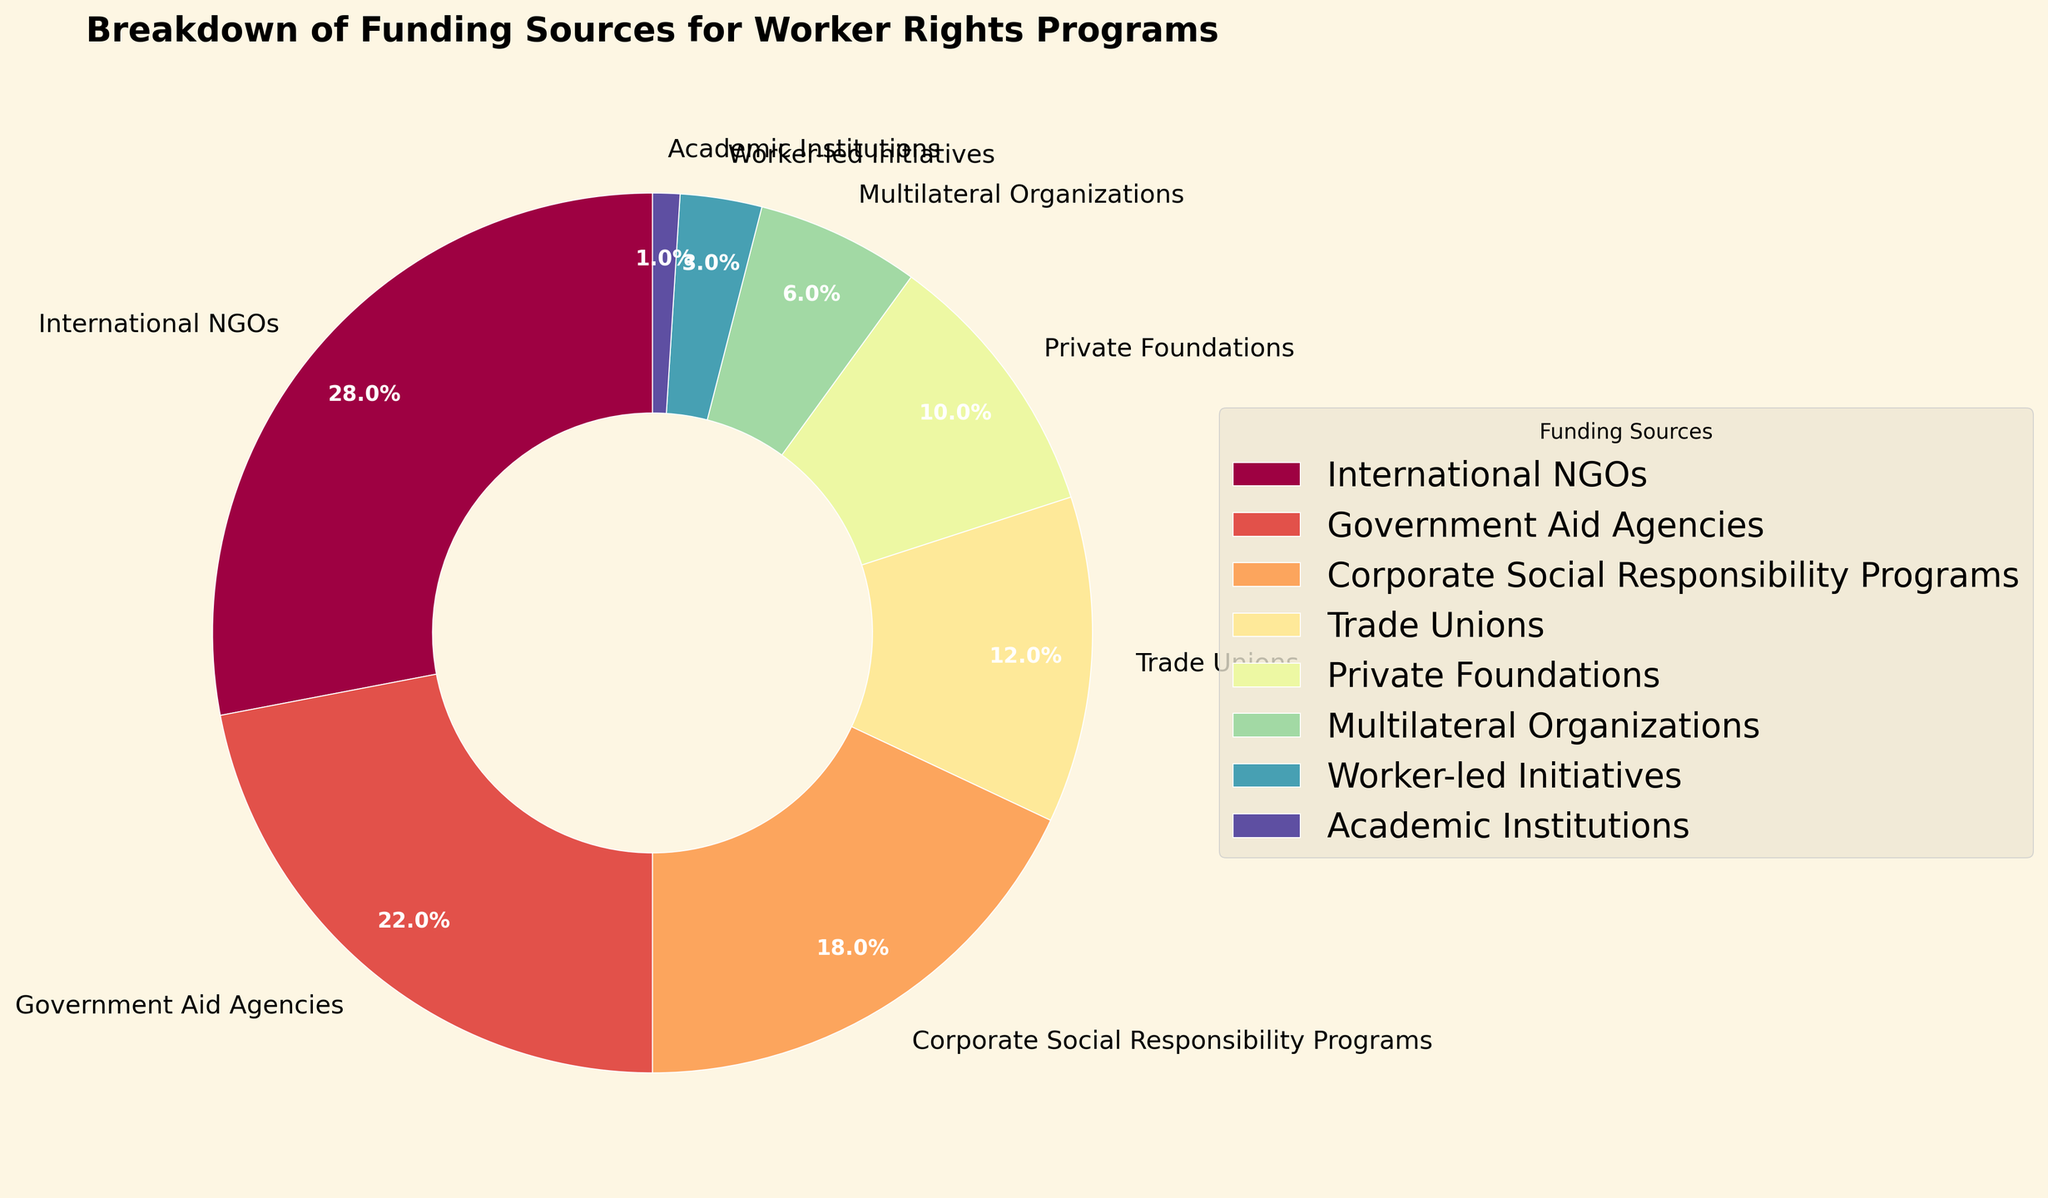What percentage of funding comes from International NGOs? The pie chart shows that International NGOs contribute 28% to the total funding.
Answer: 28% Which funding source contributes the least? By referring to the chart, we can see that Academic Institutions have the smallest slice, contributing 1%.
Answer: Academic Institutions How much more funding do Government Aid Agencies provide compared to Worker-led Initiatives? The percentages for Government Aid Agencies and Worker-led Initiatives are 22% and 3%, respectively. The difference is 22% - 3% = 19%.
Answer: 19% What is the combined percentage of all funding sources that contribute less than 10% each? Adding the percentages for Multilateral Organizations, Worker-led Initiatives, and Academic Institutions: 6% + 3% + 1% = 10%.
Answer: 10% If Trade Unions' funding were to increase by 5%, what would their new percentage be? Trade Unions currently contribute 12%. Adding 5% to it results in 12% + 5% = 17%.
Answer: 17% Which two funding sources together provide almost half of the total funding? International NGOs (28%) and Government Aid Agencies (22%) together provide 28% + 22% = 50%, which is almost half.
Answer: International NGOs and Government Aid Agencies How does the contribution from Corporate Social Responsibility Programs compare to Trade Unions? Corporate Social Responsibility Programs contribute 18%, while Trade Unions contribute 12%. 18% is greater than 12%.
Answer: Corporate Social Responsibility Programs provide more What is the average percentage of funding from all sources? Sum up all the percentages (28% + 22% + 18% + 12% + 10% + 6% + 3% + 1%) = 100%. There are 8 sources. The average is 100% / 8 = 12.5%.
Answer: 12.5% Which category has a slightly smaller contribution than Corporate Social Responsibility Programs? The pie chart shows that Government Aid Agencies contribute 22%, which is slightly smaller than Corporate Social Responsibility Programs at 18%.
Answer: Trade Unions If the contribution from Private Foundations doubled, what percentage would it represent? The current contribution from Private Foundations is 10%. Doubling this would give 10% * 2 = 20%.
Answer: 20% 